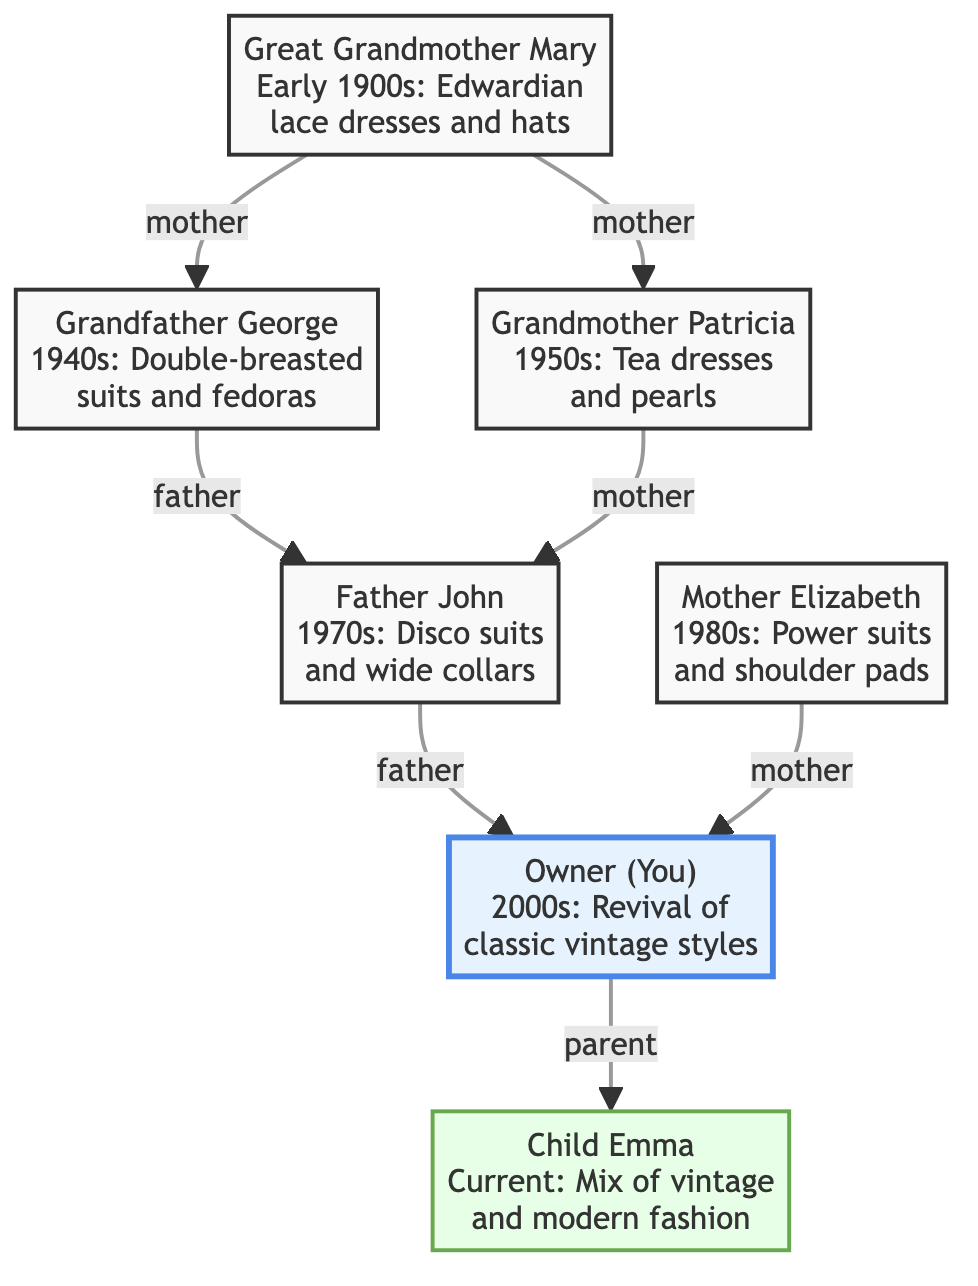What classic fashion style is associated with Great Grandmother Mary? Great Grandmother Mary is linked to the Edwardian fashion style, characterized by lace dresses and hats, as indicated in the description of her node.
Answer: Edwardian lace dresses and hats Who is the child of Father John? Looking at the diagram, Father John leads to the node labeled "Owner (You)", indicating that the Owner is his child.
Answer: Owner (You) How many generations are represented in this family history tree? Counting from Great Grandmother Mary to Child Emma, there are five generations, including Great Grandmother Mary, Grandfather George, Grandmother Patricia, Father John, and Mother Elizabeth, before reaching you and Emma.
Answer: 5 What part of the family tree represents the current fashion style? The node for Child Emma represents the current fashion style, which is depicted as a mix of vintage and modern fashion.
Answer: Child Emma Which family member's fashion style includes power suits and shoulder pads? The node for Mother Elizabeth specifically describes her fashion style as power suits and shoulder pads, as noted in her description.
Answer: Mother Elizabeth Which two family members were active in the 1970s? Both Father John and Mother Elizabeth had styles that were prominent in the 1970s and 1980s respectively, but only Father John is specifically noted to represent the styles of the 1970s.
Answer: Father John What is the relationship between Grandfather George and the Owner (You)? The diagram shows that Grandfather George is a grandfather to the Owner (You) through his child, who is either Father John or Mother Elizabeth.
Answer: Grandfather What types of fashion styles are described in the diagram? The diagram outlines a variety of fashion styles such as Edwardian lace dresses, double-breasted suits, tea dresses, disco suits, power suits, and a revival of classic vintage styles in the current generation.
Answer: Variety of classic styles Which family member connects the 1940s and 1950s fashion styles? The connection between the 1940s represented by Grandfather George and the 1950s represented by Grandmother Patricia is through their child, either through direct or marriage relation to Father John, who is part of the next generation.
Answer: Grandfather George and Grandmother Patricia 